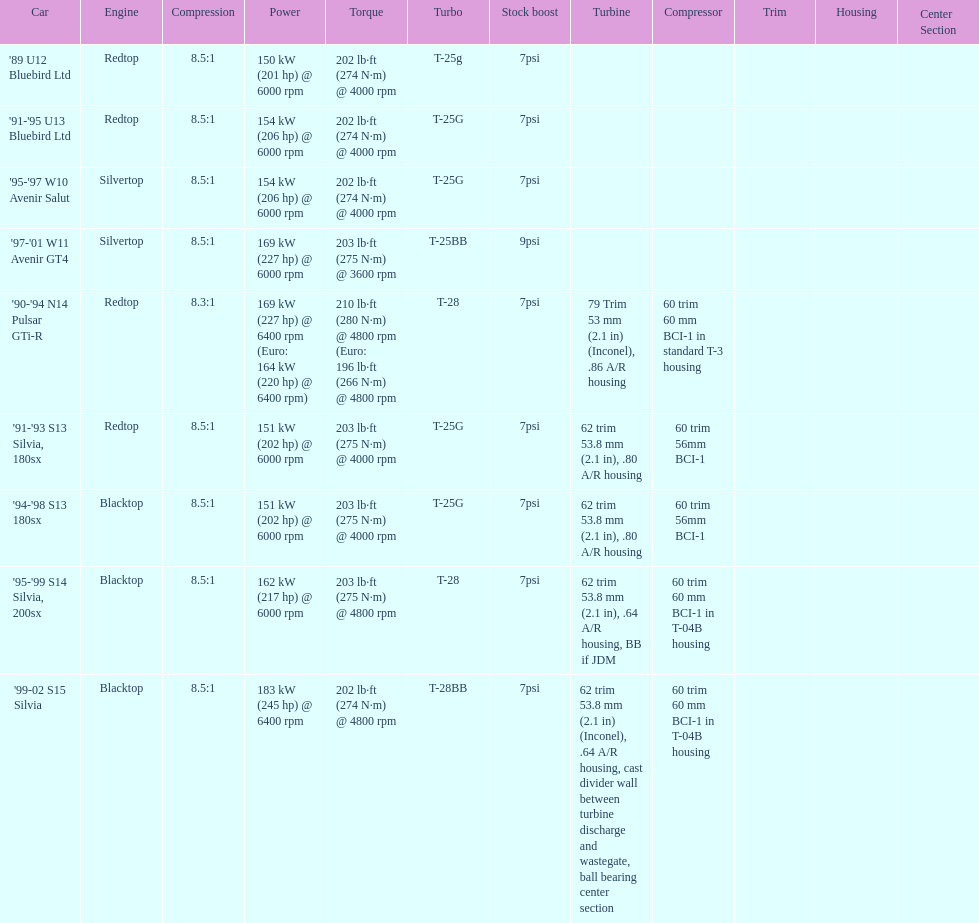Which car has a stock boost of over 7psi? '97-'01 W11 Avenir GT4. Would you mind parsing the complete table? {'header': ['Car', 'Engine', 'Compression', 'Power', 'Torque', 'Turbo', 'Stock boost', 'Turbine', 'Compressor', 'Trim', 'Housing', 'Center Section'], 'rows': [["'89 U12 Bluebird Ltd", 'Redtop', '8.5:1', '150\xa0kW (201\xa0hp) @ 6000 rpm', '202\xa0lb·ft (274\xa0N·m) @ 4000 rpm', 'T-25g', '7psi', '', '', '', '', ''], ["'91-'95 U13 Bluebird Ltd", 'Redtop', '8.5:1', '154\xa0kW (206\xa0hp) @ 6000 rpm', '202\xa0lb·ft (274\xa0N·m) @ 4000 rpm', 'T-25G', '7psi', '', '', '', '', ''], ["'95-'97 W10 Avenir Salut", 'Silvertop', '8.5:1', '154\xa0kW (206\xa0hp) @ 6000 rpm', '202\xa0lb·ft (274\xa0N·m) @ 4000 rpm', 'T-25G', '7psi', '', '', '', '', ''], ["'97-'01 W11 Avenir GT4", 'Silvertop', '8.5:1', '169\xa0kW (227\xa0hp) @ 6000 rpm', '203\xa0lb·ft (275\xa0N·m) @ 3600 rpm', 'T-25BB', '9psi', '', '', '', '', ''], ["'90-'94 N14 Pulsar GTi-R", 'Redtop', '8.3:1', '169\xa0kW (227\xa0hp) @ 6400 rpm (Euro: 164\xa0kW (220\xa0hp) @ 6400 rpm)', '210\xa0lb·ft (280\xa0N·m) @ 4800 rpm (Euro: 196\xa0lb·ft (266\xa0N·m) @ 4800 rpm', 'T-28', '7psi', '79 Trim 53\xa0mm (2.1\xa0in) (Inconel), .86 A/R housing', '60 trim 60\xa0mm BCI-1 in standard T-3 housing', '', '', ''], ["'91-'93 S13 Silvia, 180sx", 'Redtop', '8.5:1', '151\xa0kW (202\xa0hp) @ 6000 rpm', '203\xa0lb·ft (275\xa0N·m) @ 4000 rpm', 'T-25G', '7psi', '62 trim 53.8\xa0mm (2.1\xa0in), .80 A/R housing', '60 trim 56mm BCI-1', '', '', ''], ["'94-'98 S13 180sx", 'Blacktop', '8.5:1', '151\xa0kW (202\xa0hp) @ 6000 rpm', '203\xa0lb·ft (275\xa0N·m) @ 4000 rpm', 'T-25G', '7psi', '62 trim 53.8\xa0mm (2.1\xa0in), .80 A/R housing', '60 trim 56mm BCI-1', '', '', ''], ["'95-'99 S14 Silvia, 200sx", 'Blacktop', '8.5:1', '162\xa0kW (217\xa0hp) @ 6000 rpm', '203\xa0lb·ft (275\xa0N·m) @ 4800 rpm', 'T-28', '7psi', '62 trim 53.8\xa0mm (2.1\xa0in), .64 A/R housing, BB if JDM', '60 trim 60\xa0mm BCI-1 in T-04B housing', '', '', ''], ["'99-02 S15 Silvia", 'Blacktop', '8.5:1', '183\xa0kW (245\xa0hp) @ 6400 rpm', '202\xa0lb·ft (274\xa0N·m) @ 4800 rpm', 'T-28BB', '7psi', '62 trim 53.8\xa0mm (2.1\xa0in) (Inconel), .64 A/R housing, cast divider wall between turbine discharge and wastegate, ball bearing center section', '60 trim 60\xa0mm BCI-1 in T-04B housing', '', '', '']]} 